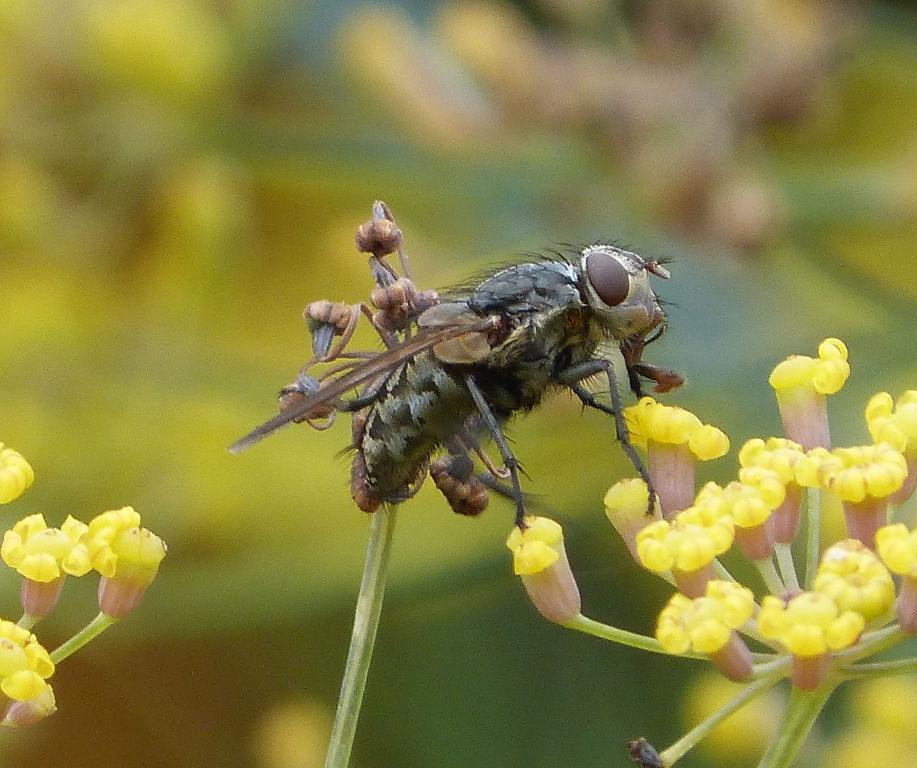What type of creature can be seen in the picture? There is an insect in the picture. What other living organisms are present in the image? There are flowers in the picture. What can be seen in the background of the image? There are plants in the background of the picture. How would you describe the clarity of the image? The image is blurry. What type of produce is being sold at the market in the image? There is no market or produce present in the image; it features an insect, flowers, and plants. What type of leather is visible on the chair in the image? There is no chair or leather present in the image. 